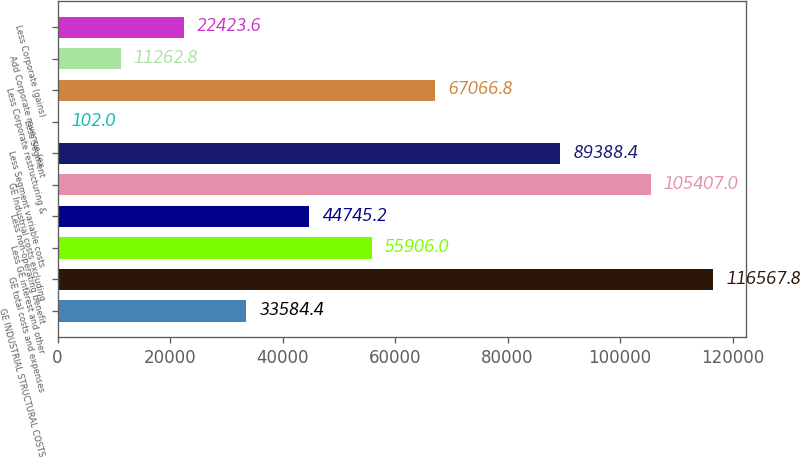<chart> <loc_0><loc_0><loc_500><loc_500><bar_chart><fcel>GE INDUSTRIAL STRUCTURAL COSTS<fcel>GE total costs and expenses<fcel>Less GE interest and other<fcel>Less non-operating benefit<fcel>GE Industrial costs excluding<fcel>Less Segment variable costs<fcel>Less Segment<fcel>Less Corporate restructuring &<fcel>Add Corporate revenue (ex<fcel>Less Corporate (gains)<nl><fcel>33584.4<fcel>116568<fcel>55906<fcel>44745.2<fcel>105407<fcel>89388.4<fcel>102<fcel>67066.8<fcel>11262.8<fcel>22423.6<nl></chart> 